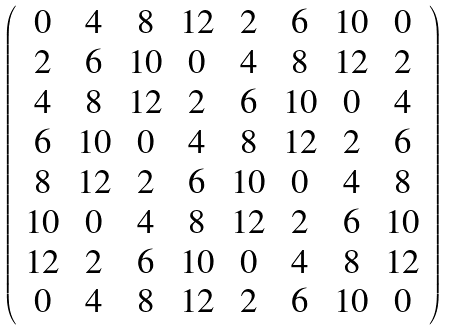Convert formula to latex. <formula><loc_0><loc_0><loc_500><loc_500>\left ( \begin{array} { c c c c c c c c } 0 & 4 & 8 & 1 2 & 2 & 6 & 1 0 & 0 \\ 2 & 6 & 1 0 & 0 & 4 & 8 & 1 2 & 2 \\ 4 & 8 & 1 2 & 2 & 6 & 1 0 & 0 & 4 \\ 6 & 1 0 & 0 & 4 & 8 & 1 2 & 2 & 6 \\ 8 & 1 2 & 2 & 6 & 1 0 & 0 & 4 & 8 \\ 1 0 & 0 & 4 & 8 & 1 2 & 2 & 6 & 1 0 \\ 1 2 & 2 & 6 & 1 0 & 0 & 4 & 8 & 1 2 \\ 0 & 4 & 8 & 1 2 & 2 & 6 & 1 0 & 0 \\ \end{array} \right )</formula> 